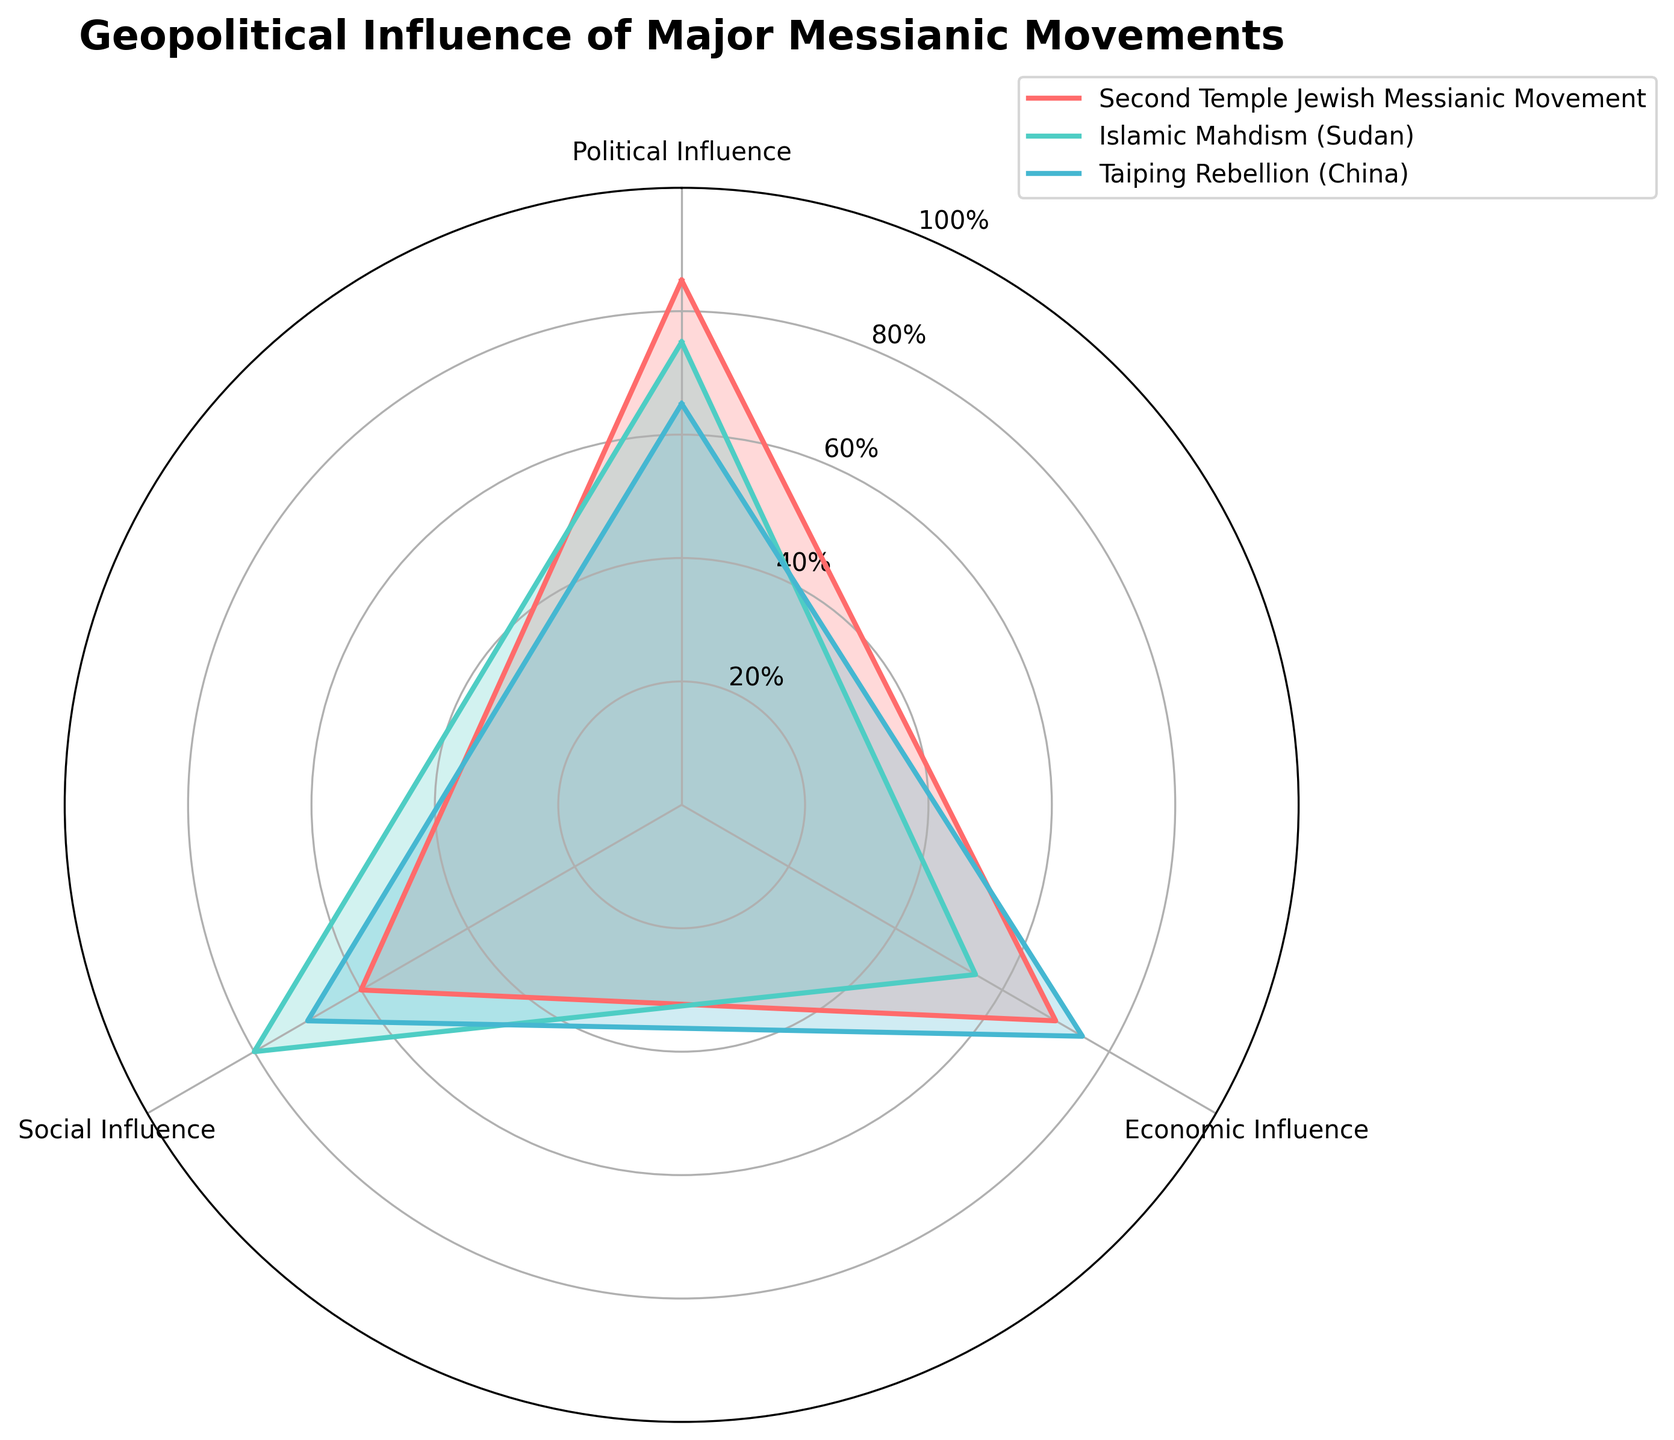What are the three categories of influence shown on the chart? The chart displays three dimensions or categories of influence: Political Influence, Economic Influence, and Social Influence, as indicated by the axes of the radar chart.
Answer: Political Influence, Economic Influence, Social Influence Which messianic movement has the highest Political Influence? By examining the axis marked "Political Influence," the Second Temple Jewish Messianic Movement shows the highest value, reaching 85.
Answer: Second Temple Jewish Messianic Movement Which messianic movement displays the lowest Economic Influence, and what is the value? The radar chart indicates values on the "Economic Influence" axis. Islamic Mahdism (Sudan) is the movement with the lowest Economic Influence, with a value of 55.
Answer: Islamic Mahdism (Sudan), 55 How does the Social Influence value of the Taiping Rebellion compare to the Social Influence of the Second Temple Jewish Messianic Movement? The Social Influence values on the chart show that the Taiping Rebellion has a value of 70, while the Second Temple Jewish Messianic Movement has a value of 60. Thus, the Taiping Rebellion has a higher Social Influence by 10.
Answer: Taiping Rebellion is higher by 10 What is the average Economic Influence of the three messianic movements? To find the average, sum the Economic Influence scores of each movement (70 + 55 + 75) to get 200, then divide by 3: 200 / 3 = 66.67
Answer: 66.67 Which movement shows the most balanced (closest to equal) influence across Political, Economic, and Social categories? By examining the disparity in the values for each category, the Taiping Rebellion has the most balanced influence with values close to each other: 65 (Political), 75 (Economic), and 70 (Social).
Answer: Taiping Rebellion By how much does Second Temple Jewish Messianic Movement outscore Islamic Mahdism (Sudan) in Political Influence? The value for Political Influence of the Second Temple Jewish Messianic Movement is 85, while for Islamic Mahdism (Sudan) it is 75. The difference is 85 - 75 = 10.
Answer: 10 If you were to rank the movements by the sum of their influences, what would be the order from highest to lowest? Calculate the sum of the influences for each movement: Second Temple Jewish Messianic Movement (85 + 70 + 60 = 215), Islamic Mahdism (Sudan) (75 + 55 + 80 = 210), Taiping Rebellion (65 + 75 + 70 = 210). Since Second Temple Jewish Messianic Movement has the highest sum, followed by both Islamic Mahdism (Sudan) and Taiping Rebellion with a tie, the order is: Second Temple Jewish Messianic Movement, Islamic Mahdism (Sudan) and Taiping Rebellion (tie).
Answer: Second Temple Jewish Messianic Movement, Islamic Mahdism (Sudan) and Taiping Rebellion (tie) Which category experiences the most significant variation in influence values among the movements? To determine the category with the most significant variation, look at the range of values: Political Influence (85, 75, 65), Economic Influence (70, 55, 75), Social Influence (60, 80, 70). Political Influence has a range of 20, Economic Influence has a range of 20, and Social Influence has a range of 20. Since each category has an equal variation of 20 units, there is no single category with the most significant variation.
Answer: Equal for all categories Which messianic movement shows the highest overall influence in any single category? Among the three aspects, the highest value noted is for Political Influence in the Second Temple Jewish Messianic Movement at 85.
Answer: Second Temple Jewish Messianic Movement 